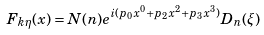Convert formula to latex. <formula><loc_0><loc_0><loc_500><loc_500>F _ { k \eta } ( x ) = N ( n ) e ^ { i ( p _ { 0 } x ^ { 0 } + p _ { 2 } x ^ { 2 } + p _ { 3 } x ^ { 3 } ) } D _ { n } ( \xi )</formula> 